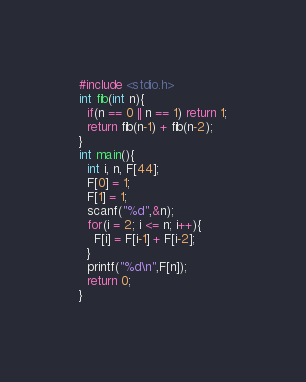Convert code to text. <code><loc_0><loc_0><loc_500><loc_500><_C_>#include <stdio.h>
int fib(int n){
  if(n == 0 || n == 1) return 1;
  return fib(n-1) + fib(n-2);
}
int main(){
  int i, n, F[44];
  F[0] = 1;
  F[1] = 1;
  scanf("%d",&n);
  for(i = 2; i <= n; i++){
    F[i] = F[i-1] + F[i-2];
  }
  printf("%d\n",F[n]);
  return 0;
}</code> 